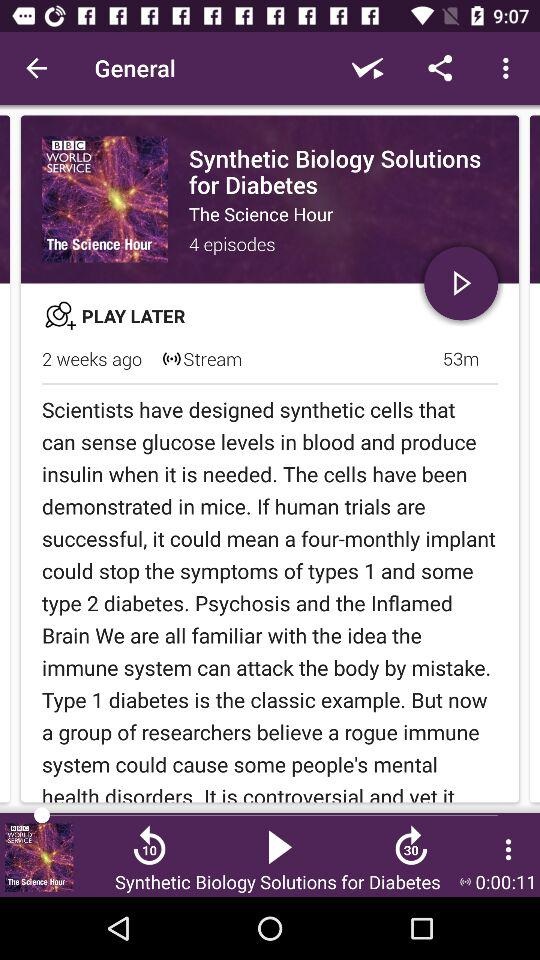How long is the episode?
Answer the question using a single word or phrase. 53m 